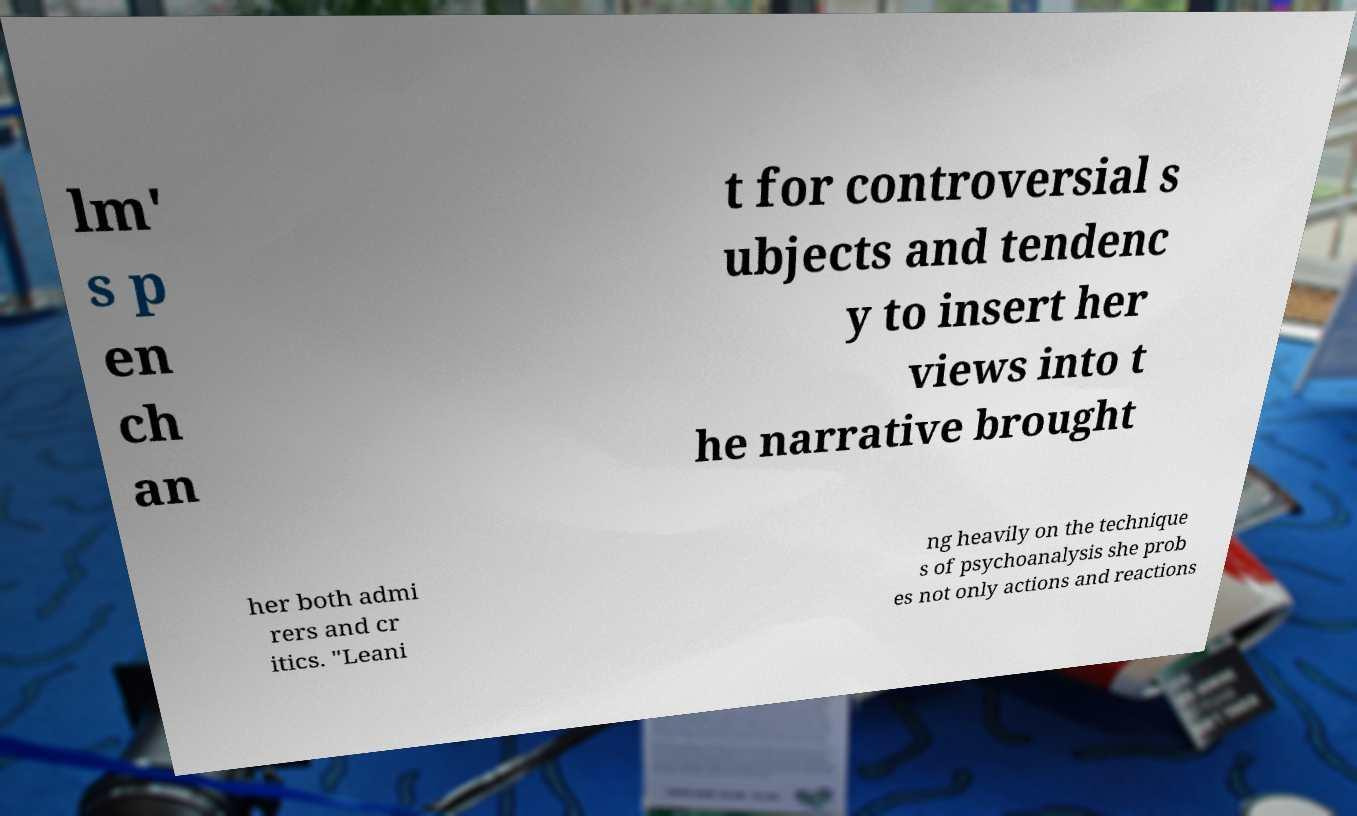Please read and relay the text visible in this image. What does it say? lm' s p en ch an t for controversial s ubjects and tendenc y to insert her views into t he narrative brought her both admi rers and cr itics. "Leani ng heavily on the technique s of psychoanalysis she prob es not only actions and reactions 